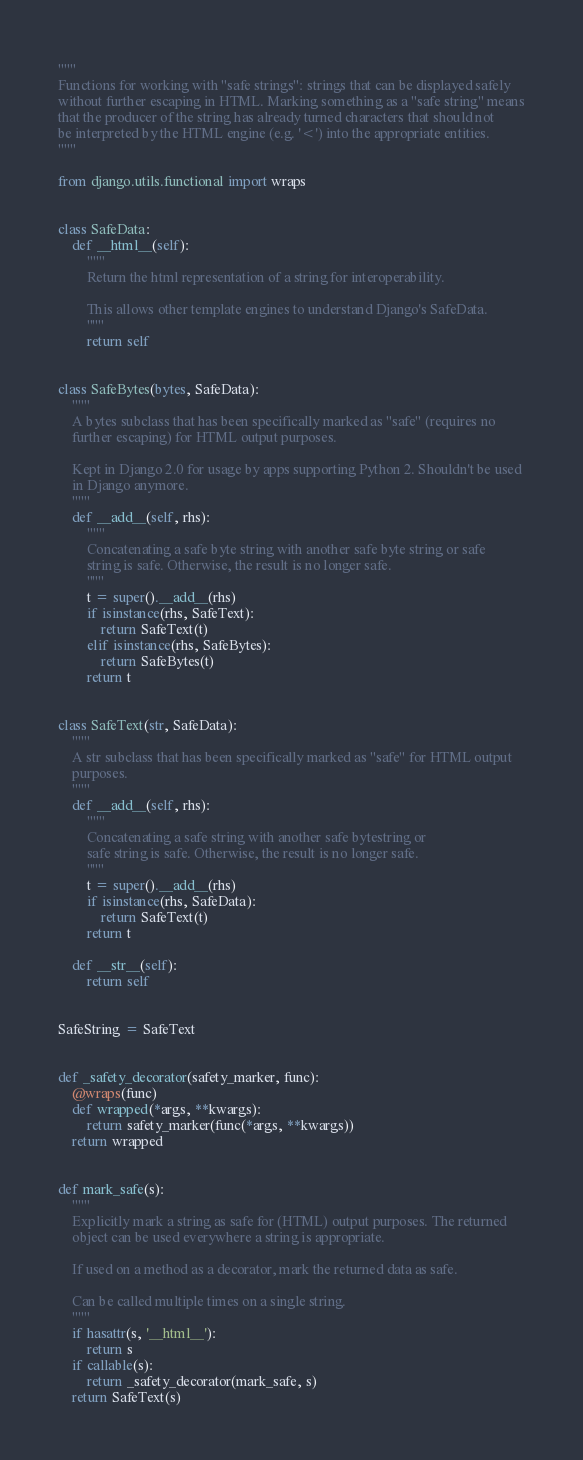Convert code to text. <code><loc_0><loc_0><loc_500><loc_500><_Python_>"""
Functions for working with "safe strings": strings that can be displayed safely
without further escaping in HTML. Marking something as a "safe string" means
that the producer of the string has already turned characters that should not
be interpreted by the HTML engine (e.g. '<') into the appropriate entities.
"""

from django.utils.functional import wraps


class SafeData:
    def __html__(self):
        """
        Return the html representation of a string for interoperability.

        This allows other template engines to understand Django's SafeData.
        """
        return self


class SafeBytes(bytes, SafeData):
    """
    A bytes subclass that has been specifically marked as "safe" (requires no
    further escaping) for HTML output purposes.

    Kept in Django 2.0 for usage by apps supporting Python 2. Shouldn't be used
    in Django anymore.
    """
    def __add__(self, rhs):
        """
        Concatenating a safe byte string with another safe byte string or safe
        string is safe. Otherwise, the result is no longer safe.
        """
        t = super().__add__(rhs)
        if isinstance(rhs, SafeText):
            return SafeText(t)
        elif isinstance(rhs, SafeBytes):
            return SafeBytes(t)
        return t


class SafeText(str, SafeData):
    """
    A str subclass that has been specifically marked as "safe" for HTML output
    purposes.
    """
    def __add__(self, rhs):
        """
        Concatenating a safe string with another safe bytestring or
        safe string is safe. Otherwise, the result is no longer safe.
        """
        t = super().__add__(rhs)
        if isinstance(rhs, SafeData):
            return SafeText(t)
        return t

    def __str__(self):
        return self


SafeString = SafeText


def _safety_decorator(safety_marker, func):
    @wraps(func)
    def wrapped(*args, **kwargs):
        return safety_marker(func(*args, **kwargs))
    return wrapped


def mark_safe(s):
    """
    Explicitly mark a string as safe for (HTML) output purposes. The returned
    object can be used everywhere a string is appropriate.

    If used on a method as a decorator, mark the returned data as safe.

    Can be called multiple times on a single string.
    """
    if hasattr(s, '__html__'):
        return s
    if callable(s):
        return _safety_decorator(mark_safe, s)
    return SafeText(s)
</code> 